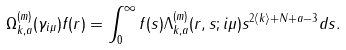Convert formula to latex. <formula><loc_0><loc_0><loc_500><loc_500>\Omega _ { k , a } ^ { ( m ) } ( \gamma _ { i \mu } ) f ( r ) = \int _ { 0 } ^ { \infty } f ( s ) \Lambda _ { k , a } ^ { ( m ) } ( r , s ; i \mu ) s ^ { 2 \langle k \rangle + N + a - 3 } d s .</formula> 